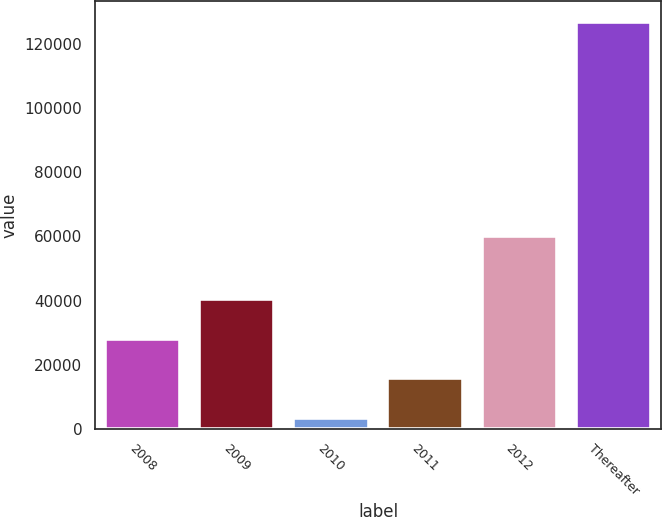Convert chart to OTSL. <chart><loc_0><loc_0><loc_500><loc_500><bar_chart><fcel>2008<fcel>2009<fcel>2010<fcel>2011<fcel>2012<fcel>Thereafter<nl><fcel>28080.8<fcel>40443.2<fcel>3356<fcel>15718.4<fcel>60200<fcel>126980<nl></chart> 